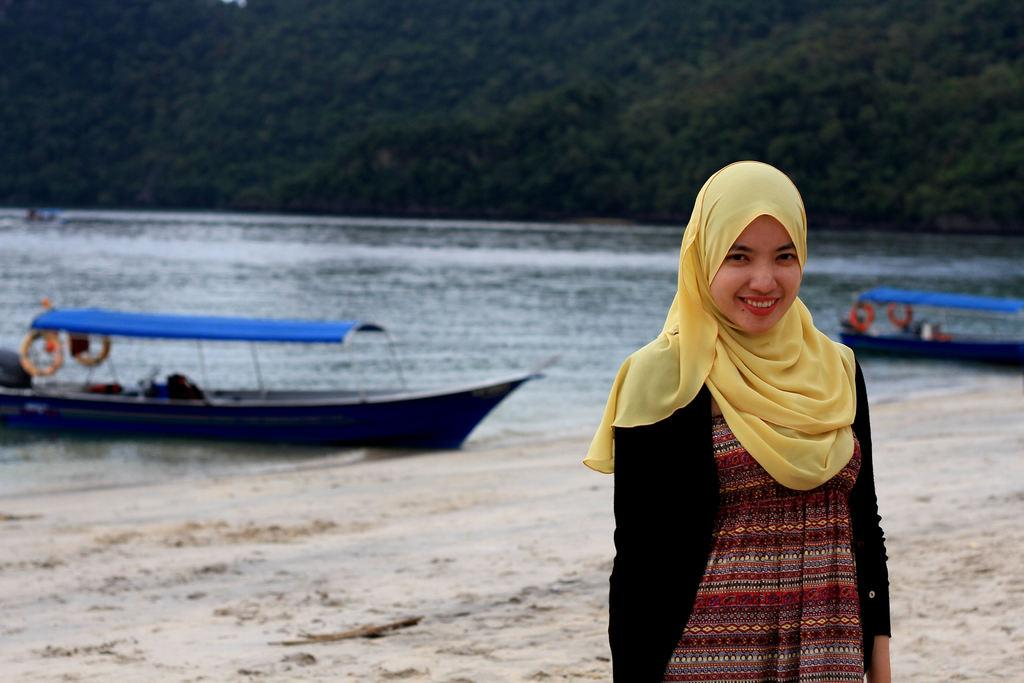What is located on the right side of the image? There is a girl on the right side of the image. What can be seen in the background of the image? There are boats in the water in the background of the image. What type of vegetation is at the top side of the image? There are trees at the top side of the image. Where is the badge located in the image? There is no badge present in the image. What type of flock is visible in the image? There is no flock visible in the image. 